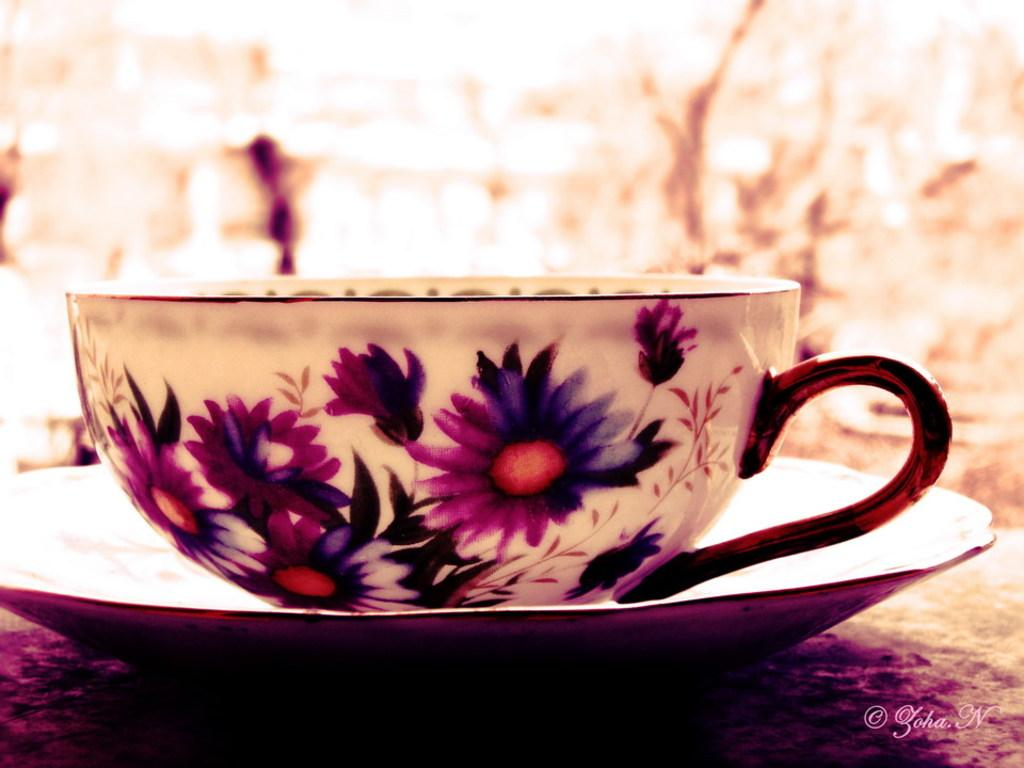What is present in the image that can hold liquids? There is a cup in the image that can hold liquids. Is there anything accompanying the cup in the image? Yes, there is a saucer in the image. What design or pattern is on the cup? The cup has flower paintings on it. What type of collar can be seen on the cup in the image? There is no collar present on the cup in the image; it is a ceramic cup with flower paintings. 